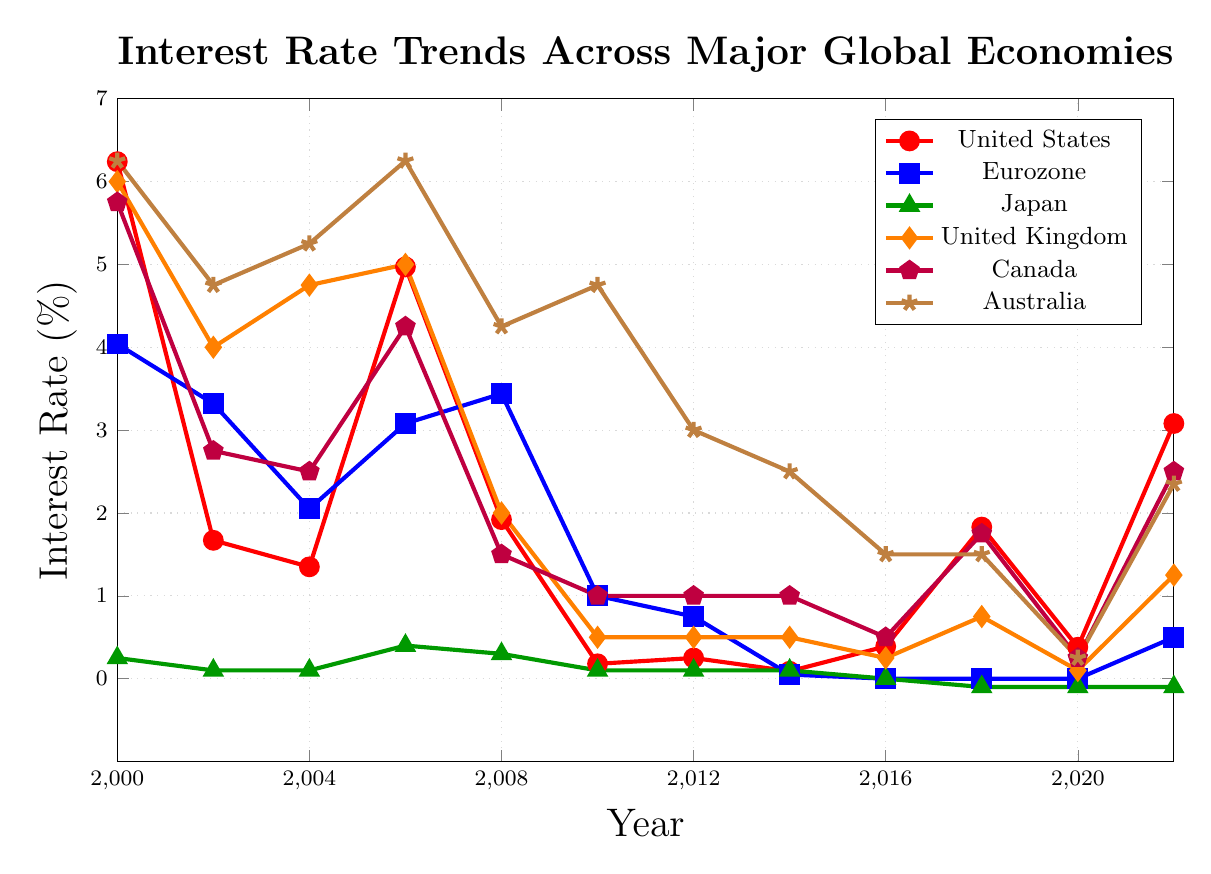What was the highest interest rate for the United States and in which year? The highest value for the United States can be found by visually inspecting the red line on the chart. The highest peak is in the year 2000 with a value of 6.24%.
Answer: 6.24% in 2000 Which economy had the lowest interest rate in 2018? By checking the 2018 values for all the economies, the lowest interest rate is for Japan which is -0.1%.
Answer: Japan Between 2000 and 2014, in which year did the Eurozone’s interest rate drop the most compared to the previous year? Looking at the blue line representing the Eurozone, the most significant drop is from 2008 to 2010, dropping from 3.44% to 1.00% (a difference of 2.44%).
Answer: 2008 to 2010 Compare the trend of interest rates between the United Kingdom and Canada from 2002 to 2012. Which economy had a generally lower interest rate? By inspecting the orange and purple lines between 2002 and 2012, we see that the United Kingdom had higher rates than Canada in earlier years (2002-2004) but since then, both followed a similar downward trend with the United Kingdom generally higher than Canada until 2012.
Answer: Canada What is the difference in interest rate for Australia between 2000 and 2022? From the brown line, Australia’s interest rate in 2000 was 6.25% and in 2022 it was 2.35%. The difference is 6.25% - 2.35%.
Answer: 3.9% Which two economies had opposite trends in interest rates during the period from 2016 to 2018? The green line (Japan) shows a decrease in interest rates, while the red line (United States) shows an increase during this period.
Answer: Japan and United States Identify a three-year period where the interest rate for the United States remained almost constant. From 2014 to 2016, the red line shows that the interest rates for the United States were relatively steady at around 0.09% to 0.39%.
Answer: 2014-2016 What was the average interest rate for Japan from 2016 to 2022? Looking at the green line for Japan, the rates from 2016 to 2022 were 0.0%, -0.1%, -0.1%, -0.1%. Summing these and dividing by 4 years gives an average (0 + (-0.1) + (-0.1) + (-0.1)) / 4 = -0.075%.
Answer: -0.075% How has the Eurozone's interest rate changed from 2010 to 2022? The interest rate for the Eurozone (blue line) decreased from 1.00% in 2010 to 0.50% by 2022, with a notable period at 0.0% from 2016 to 2020.
Answer: Decreased to 0.50% Which country’s interest rate fluctuated the most over the years shown? By visually inspecting all the lines, the orange line representing the United Kingdom shows significant fluctuations with rates ranging widely between the years.
Answer: United Kingdom 